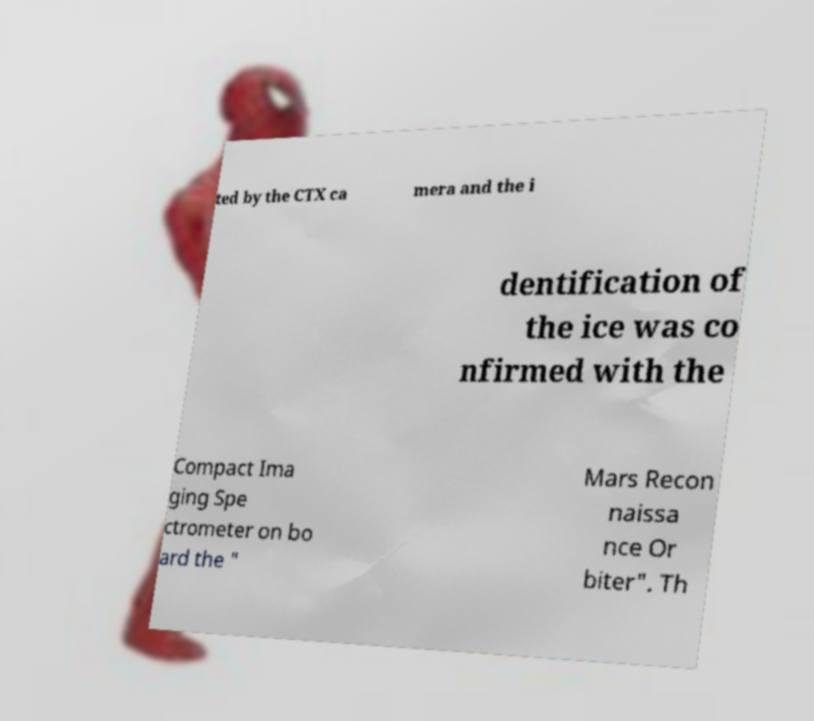Please read and relay the text visible in this image. What does it say? ted by the CTX ca mera and the i dentification of the ice was co nfirmed with the Compact Ima ging Spe ctrometer on bo ard the " Mars Recon naissa nce Or biter". Th 